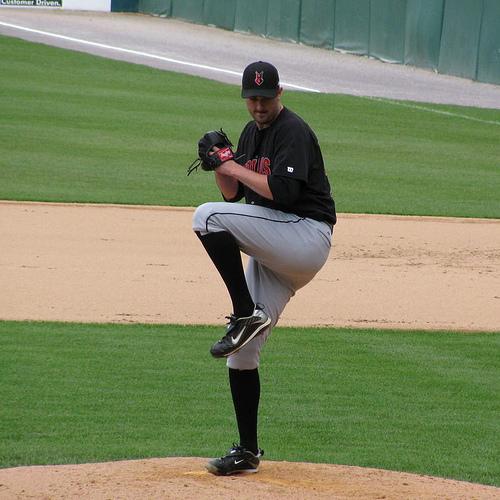What is the color shirt?
Give a very brief answer. Black. What sport is this?
Answer briefly. Baseball. How is the subject of the photo?
Answer briefly. Pitcher. What is the man about to do?
Answer briefly. Pitch. 